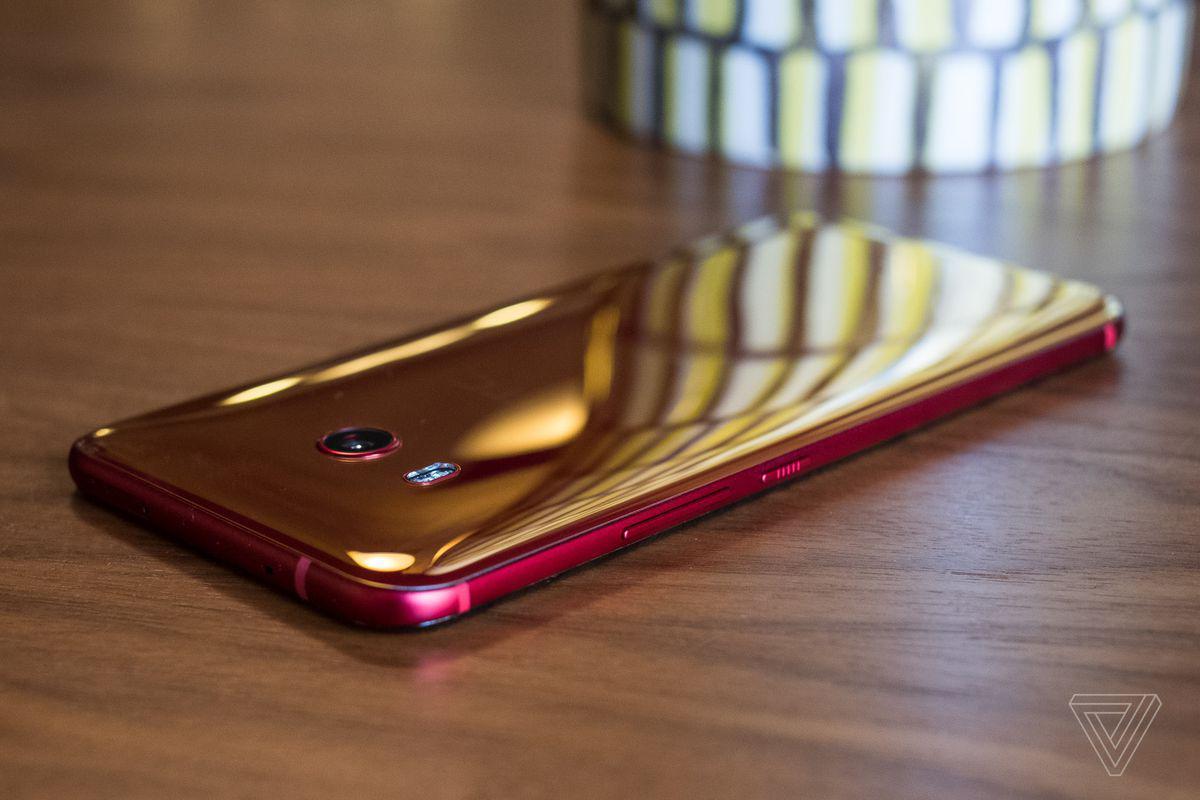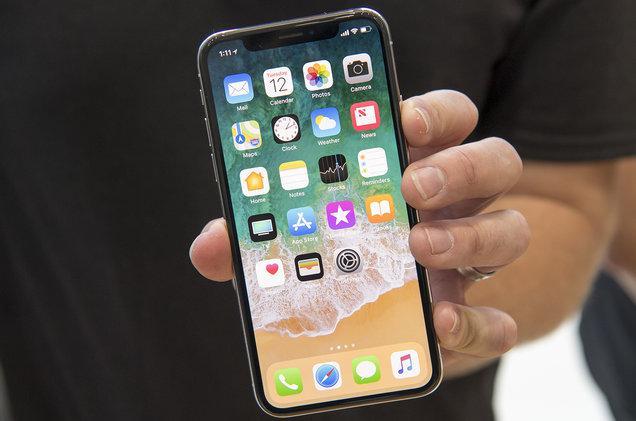The first image is the image on the left, the second image is the image on the right. For the images displayed, is the sentence "Each of the images shows a female holding and looking at a cell phone." factually correct? Answer yes or no. No. The first image is the image on the left, the second image is the image on the right. Considering the images on both sides, is "There are two brown haired women holding their phones." valid? Answer yes or no. No. 